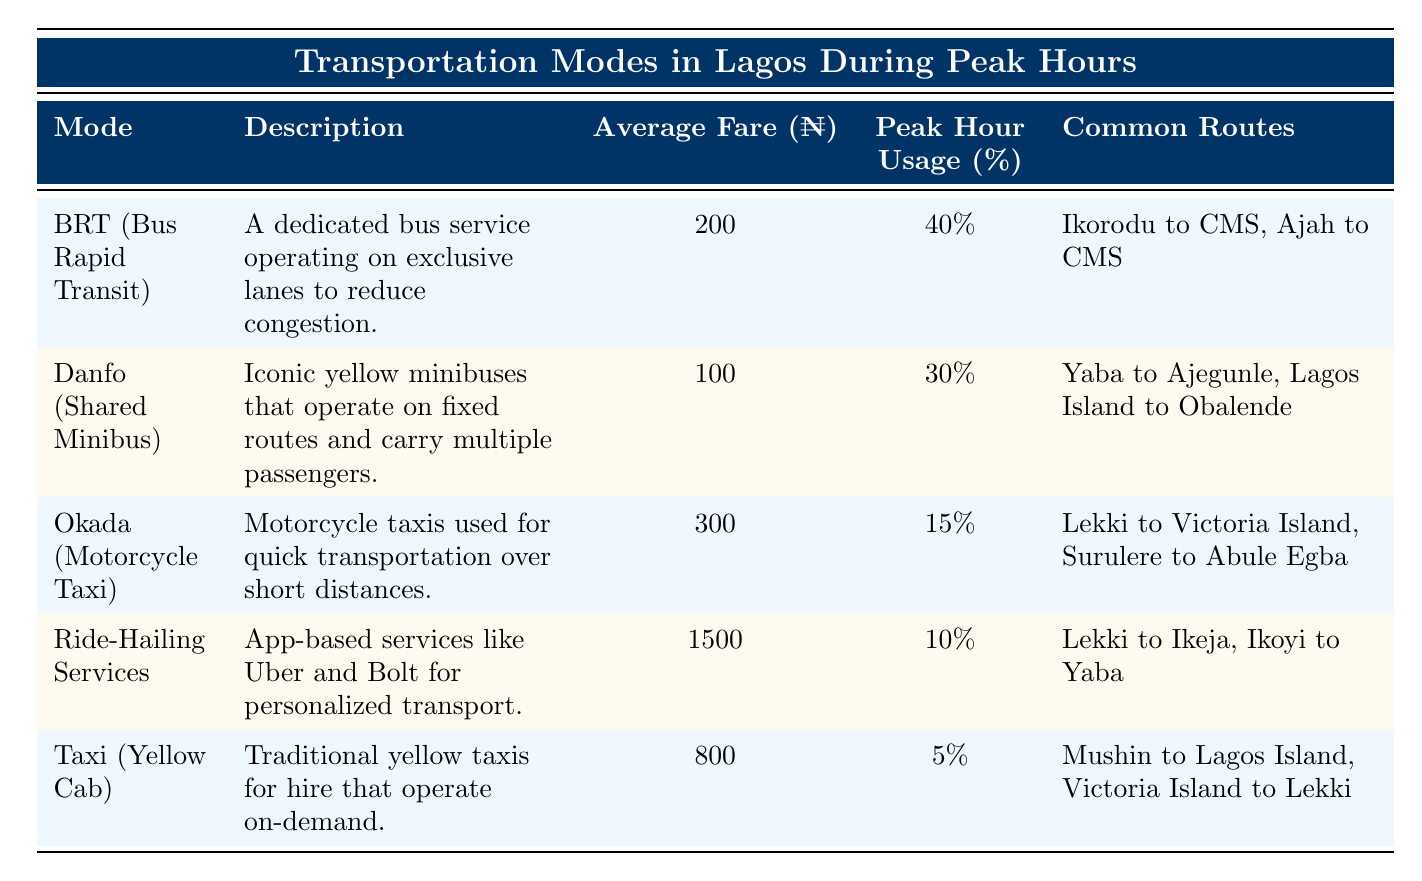What is the average fare for BRT? The fare for BRT (Bus Rapid Transit) is listed in the table as 200 Naira.
Answer: 200 Naira Which transportation mode has the highest peak hour usage percentage? According to the table, BRT (Bus Rapid Transit) has the highest peak hour usage percentage at 40%.
Answer: BRT (Bus Rapid Transit) What is the combined peak hour usage percentage of Danfo and Okada? To find the combined peak hour usage percentage of Danfo (30%) and Okada (15%), we add the two values: 30% + 15% = 45%.
Answer: 45% Is the average fare for Ride-Hailing Services greater than that of Danfo? The average fare for Ride-Hailing Services is 1500 Naira, while Danfo's average fare is 100 Naira. Therefore, it is true that Ride-Hailing Services is greater.
Answer: Yes Which common route is associated with both Danfo and Okada? The common route for Danfo is "Yaba to Ajegunle" and for Okada it is "Lekki to Victoria Island." There are no overlapping routes between them. Therefore, there are no common routes.
Answer: No What is the difference between the average fares of Okada and Taxi? The average fare for Okada is 300 Naira and for Taxi it is 800 Naira. The difference is calculated as 800 Naira - 300 Naira = 500 Naira.
Answer: 500 Naira Which transportation mode is least used during peak hours? The table shows that Taxi (Yellow Cab) has the lowest peak hour usage percentage at 5%.
Answer: Taxi (Yellow Cab) How many transportation modes have an average fare less than 300 Naira? Based on the table, the average fares under 300 Naira are for BRT (200 Naira), Danfo (100 Naira), and Okada (300 Naira). Thus, there are two transportation modes below 300 Naira: BRT and Danfo.
Answer: 2 